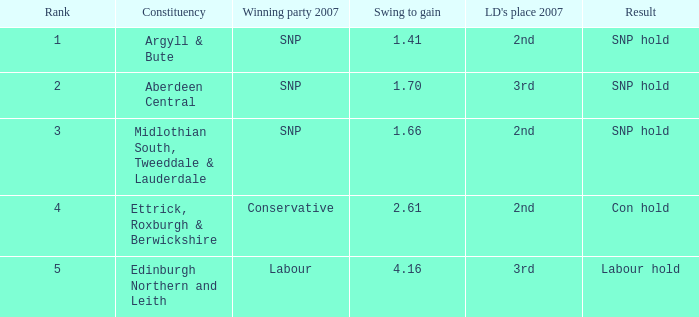What is the constituency when the rank is less than 5 and the result is con hold? Ettrick, Roxburgh & Berwickshire. 